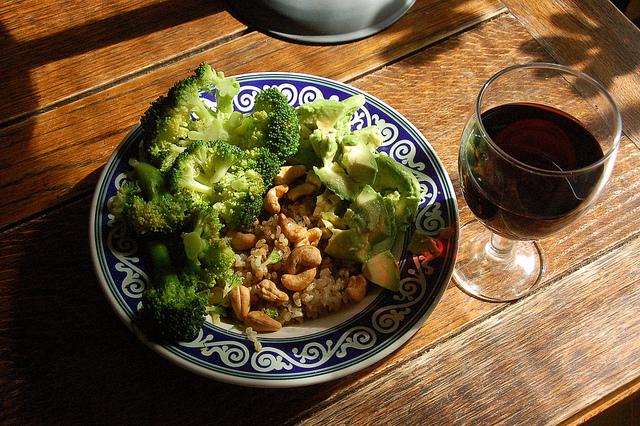What vegetable is on the plate?
Give a very brief answer. Broccoli. Is there an eating utensil in the bowl?
Write a very short answer. No. What is cut up in the bowl?
Be succinct. Avocado. Does it taste better with the wine?
Quick response, please. Yes. What pattern is on the plate?
Quick response, please. Swirls. Is this lunch or dinner?
Give a very brief answer. Dinner. 